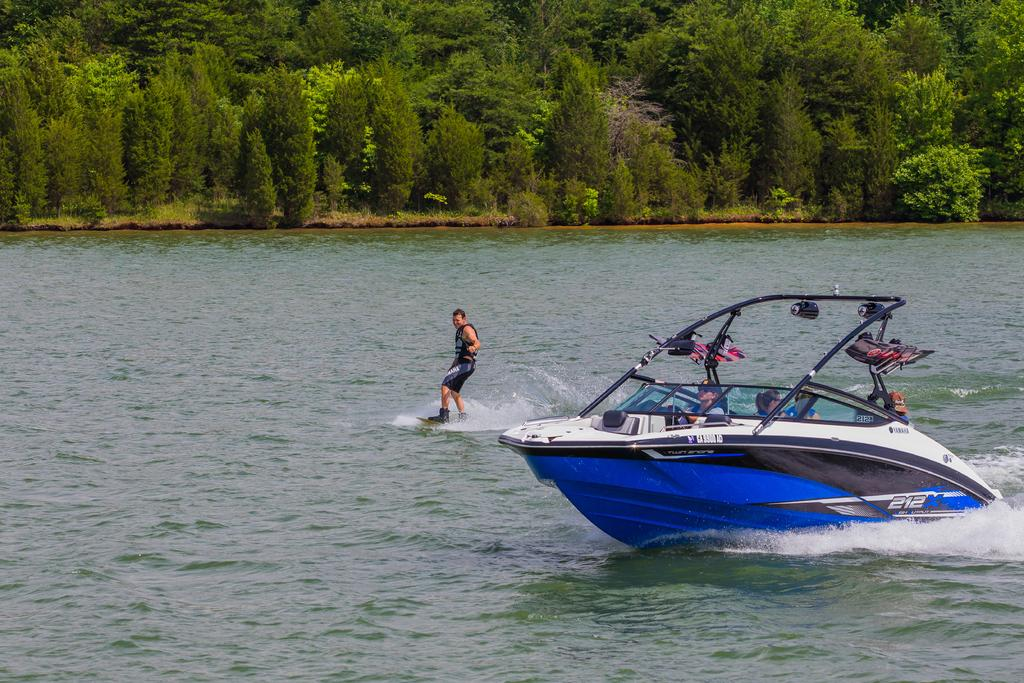What are the people in the image doing? The people in the image are seated in a boat. What activity is taking place in the water near the boat? A man is wake surfing in the water. What type of vegetation can be seen in the image? Trees are visible in the image. What type of pest can be seen crawling on the trees in the image? There is no pest visible on the trees in the image. Where is the hall located in the image? There is no hall present in the image. 